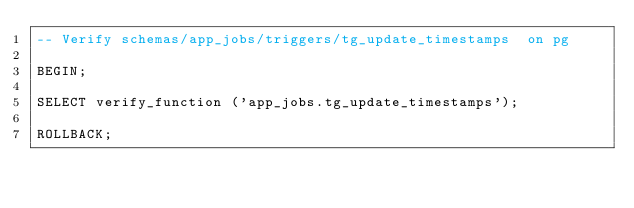<code> <loc_0><loc_0><loc_500><loc_500><_SQL_>-- Verify schemas/app_jobs/triggers/tg_update_timestamps  on pg

BEGIN;

SELECT verify_function ('app_jobs.tg_update_timestamps');

ROLLBACK;
</code> 